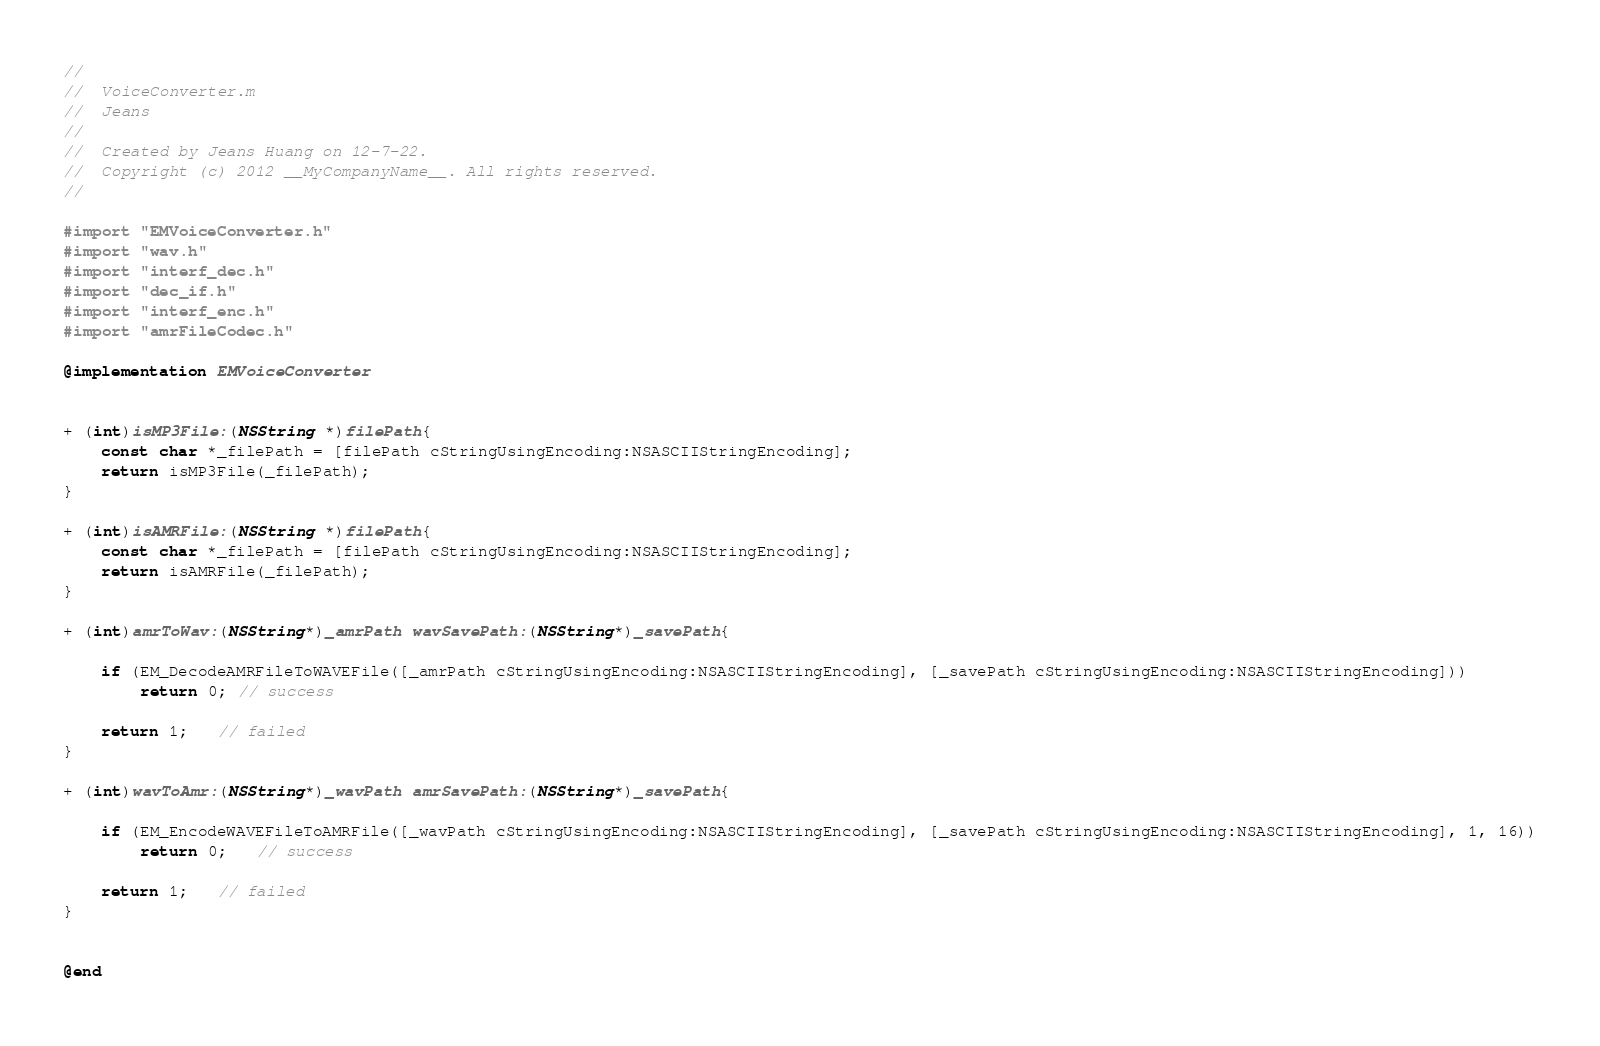Convert code to text. <code><loc_0><loc_0><loc_500><loc_500><_ObjectiveC_>//
//  VoiceConverter.m
//  Jeans
//
//  Created by Jeans Huang on 12-7-22.
//  Copyright (c) 2012 __MyCompanyName__. All rights reserved.
//

#import "EMVoiceConverter.h"
#import "wav.h"
#import "interf_dec.h"
#import "dec_if.h"
#import "interf_enc.h"
#import "amrFileCodec.h"

@implementation EMVoiceConverter


+ (int)isMP3File:(NSString *)filePath{
    const char *_filePath = [filePath cStringUsingEncoding:NSASCIIStringEncoding];
    return isMP3File(_filePath);
}

+ (int)isAMRFile:(NSString *)filePath{
    const char *_filePath = [filePath cStringUsingEncoding:NSASCIIStringEncoding];
    return isAMRFile(_filePath);
}

+ (int)amrToWav:(NSString*)_amrPath wavSavePath:(NSString*)_savePath{
    
    if (EM_DecodeAMRFileToWAVEFile([_amrPath cStringUsingEncoding:NSASCIIStringEncoding], [_savePath cStringUsingEncoding:NSASCIIStringEncoding]))
        return 0; // success
    
    return 1;   // failed
}

+ (int)wavToAmr:(NSString*)_wavPath amrSavePath:(NSString*)_savePath{
    
    if (EM_EncodeWAVEFileToAMRFile([_wavPath cStringUsingEncoding:NSASCIIStringEncoding], [_savePath cStringUsingEncoding:NSASCIIStringEncoding], 1, 16))
        return 0;   // success
    
    return 1;   // failed
}
    
    
@end
</code> 